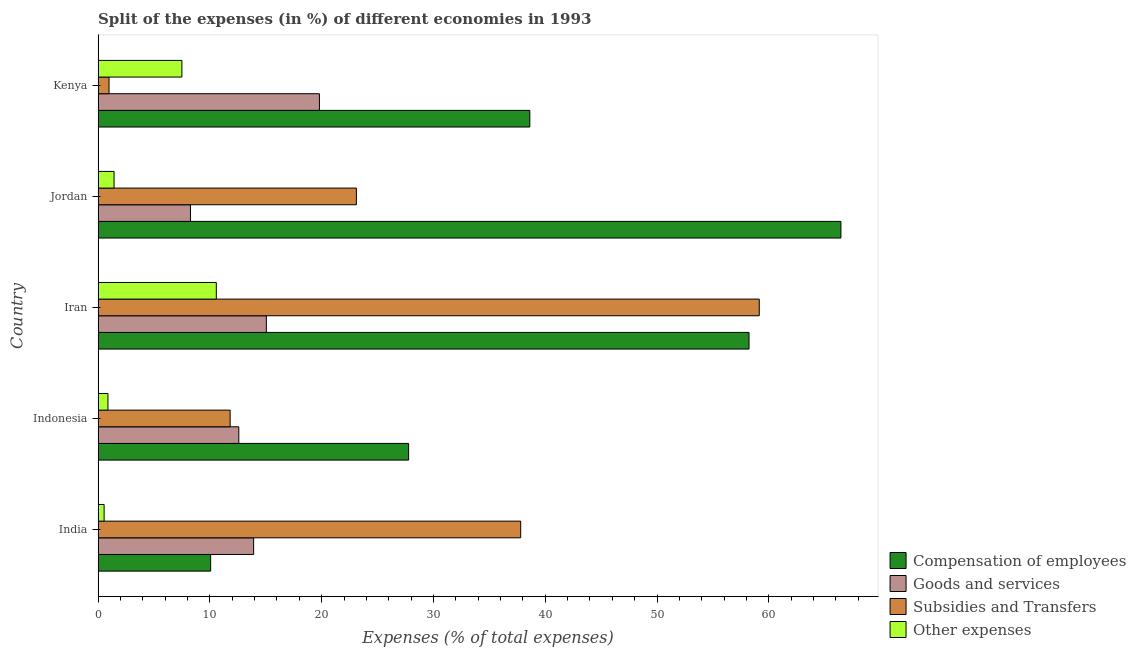How many different coloured bars are there?
Give a very brief answer. 4. How many groups of bars are there?
Provide a succinct answer. 5. How many bars are there on the 4th tick from the top?
Provide a short and direct response. 4. What is the label of the 1st group of bars from the top?
Make the answer very short. Kenya. In how many cases, is the number of bars for a given country not equal to the number of legend labels?
Your answer should be compact. 0. What is the percentage of amount spent on compensation of employees in Indonesia?
Offer a terse response. 27.78. Across all countries, what is the maximum percentage of amount spent on subsidies?
Your answer should be compact. 59.15. Across all countries, what is the minimum percentage of amount spent on other expenses?
Ensure brevity in your answer.  0.54. In which country was the percentage of amount spent on other expenses maximum?
Give a very brief answer. Iran. In which country was the percentage of amount spent on goods and services minimum?
Keep it short and to the point. Jordan. What is the total percentage of amount spent on goods and services in the graph?
Provide a short and direct response. 69.61. What is the difference between the percentage of amount spent on other expenses in Iran and that in Kenya?
Provide a short and direct response. 3.08. What is the difference between the percentage of amount spent on compensation of employees in Kenya and the percentage of amount spent on other expenses in Jordan?
Your answer should be very brief. 37.19. What is the average percentage of amount spent on other expenses per country?
Provide a succinct answer. 4.18. What is the difference between the percentage of amount spent on goods and services and percentage of amount spent on other expenses in Indonesia?
Provide a short and direct response. 11.71. What is the ratio of the percentage of amount spent on other expenses in India to that in Indonesia?
Your answer should be compact. 0.61. Is the percentage of amount spent on goods and services in India less than that in Iran?
Your answer should be very brief. Yes. What is the difference between the highest and the second highest percentage of amount spent on subsidies?
Keep it short and to the point. 21.34. What is the difference between the highest and the lowest percentage of amount spent on goods and services?
Provide a short and direct response. 11.53. What does the 1st bar from the top in India represents?
Keep it short and to the point. Other expenses. What does the 2nd bar from the bottom in Jordan represents?
Provide a short and direct response. Goods and services. How many bars are there?
Give a very brief answer. 20. Are all the bars in the graph horizontal?
Provide a succinct answer. Yes. How many countries are there in the graph?
Give a very brief answer. 5. Does the graph contain grids?
Your answer should be very brief. No. Where does the legend appear in the graph?
Keep it short and to the point. Bottom right. What is the title of the graph?
Your response must be concise. Split of the expenses (in %) of different economies in 1993. Does "Corruption" appear as one of the legend labels in the graph?
Offer a very short reply. No. What is the label or title of the X-axis?
Your response must be concise. Expenses (% of total expenses). What is the Expenses (% of total expenses) of Compensation of employees in India?
Give a very brief answer. 10.07. What is the Expenses (% of total expenses) of Goods and services in India?
Your response must be concise. 13.91. What is the Expenses (% of total expenses) in Subsidies and Transfers in India?
Your response must be concise. 37.8. What is the Expenses (% of total expenses) of Other expenses in India?
Provide a succinct answer. 0.54. What is the Expenses (% of total expenses) of Compensation of employees in Indonesia?
Your response must be concise. 27.78. What is the Expenses (% of total expenses) in Goods and services in Indonesia?
Your answer should be compact. 12.59. What is the Expenses (% of total expenses) of Subsidies and Transfers in Indonesia?
Ensure brevity in your answer.  11.81. What is the Expenses (% of total expenses) in Other expenses in Indonesia?
Your response must be concise. 0.88. What is the Expenses (% of total expenses) of Compensation of employees in Iran?
Provide a succinct answer. 58.23. What is the Expenses (% of total expenses) of Goods and services in Iran?
Give a very brief answer. 15.05. What is the Expenses (% of total expenses) of Subsidies and Transfers in Iran?
Offer a terse response. 59.15. What is the Expenses (% of total expenses) of Other expenses in Iran?
Offer a terse response. 10.57. What is the Expenses (% of total expenses) in Compensation of employees in Jordan?
Offer a terse response. 66.45. What is the Expenses (% of total expenses) in Goods and services in Jordan?
Give a very brief answer. 8.26. What is the Expenses (% of total expenses) in Subsidies and Transfers in Jordan?
Offer a terse response. 23.1. What is the Expenses (% of total expenses) of Other expenses in Jordan?
Offer a terse response. 1.43. What is the Expenses (% of total expenses) of Compensation of employees in Kenya?
Provide a succinct answer. 38.62. What is the Expenses (% of total expenses) of Goods and services in Kenya?
Provide a succinct answer. 19.8. What is the Expenses (% of total expenses) of Subsidies and Transfers in Kenya?
Your answer should be compact. 0.98. What is the Expenses (% of total expenses) in Other expenses in Kenya?
Your answer should be compact. 7.49. Across all countries, what is the maximum Expenses (% of total expenses) in Compensation of employees?
Offer a very short reply. 66.45. Across all countries, what is the maximum Expenses (% of total expenses) of Goods and services?
Offer a terse response. 19.8. Across all countries, what is the maximum Expenses (% of total expenses) in Subsidies and Transfers?
Your answer should be compact. 59.15. Across all countries, what is the maximum Expenses (% of total expenses) of Other expenses?
Your response must be concise. 10.57. Across all countries, what is the minimum Expenses (% of total expenses) in Compensation of employees?
Provide a short and direct response. 10.07. Across all countries, what is the minimum Expenses (% of total expenses) in Goods and services?
Make the answer very short. 8.26. Across all countries, what is the minimum Expenses (% of total expenses) in Subsidies and Transfers?
Your response must be concise. 0.98. Across all countries, what is the minimum Expenses (% of total expenses) in Other expenses?
Make the answer very short. 0.54. What is the total Expenses (% of total expenses) of Compensation of employees in the graph?
Offer a terse response. 201.15. What is the total Expenses (% of total expenses) in Goods and services in the graph?
Your answer should be very brief. 69.61. What is the total Expenses (% of total expenses) in Subsidies and Transfers in the graph?
Your answer should be very brief. 132.84. What is the total Expenses (% of total expenses) of Other expenses in the graph?
Provide a succinct answer. 20.91. What is the difference between the Expenses (% of total expenses) of Compensation of employees in India and that in Indonesia?
Ensure brevity in your answer.  -17.71. What is the difference between the Expenses (% of total expenses) of Goods and services in India and that in Indonesia?
Offer a very short reply. 1.33. What is the difference between the Expenses (% of total expenses) of Subsidies and Transfers in India and that in Indonesia?
Provide a short and direct response. 25.99. What is the difference between the Expenses (% of total expenses) in Other expenses in India and that in Indonesia?
Offer a terse response. -0.34. What is the difference between the Expenses (% of total expenses) in Compensation of employees in India and that in Iran?
Give a very brief answer. -48.16. What is the difference between the Expenses (% of total expenses) in Goods and services in India and that in Iran?
Offer a terse response. -1.14. What is the difference between the Expenses (% of total expenses) of Subsidies and Transfers in India and that in Iran?
Your response must be concise. -21.34. What is the difference between the Expenses (% of total expenses) in Other expenses in India and that in Iran?
Your response must be concise. -10.04. What is the difference between the Expenses (% of total expenses) of Compensation of employees in India and that in Jordan?
Your response must be concise. -56.38. What is the difference between the Expenses (% of total expenses) in Goods and services in India and that in Jordan?
Provide a short and direct response. 5.65. What is the difference between the Expenses (% of total expenses) in Subsidies and Transfers in India and that in Jordan?
Offer a terse response. 14.7. What is the difference between the Expenses (% of total expenses) of Other expenses in India and that in Jordan?
Provide a succinct answer. -0.89. What is the difference between the Expenses (% of total expenses) in Compensation of employees in India and that in Kenya?
Provide a short and direct response. -28.55. What is the difference between the Expenses (% of total expenses) of Goods and services in India and that in Kenya?
Offer a terse response. -5.89. What is the difference between the Expenses (% of total expenses) of Subsidies and Transfers in India and that in Kenya?
Provide a succinct answer. 36.83. What is the difference between the Expenses (% of total expenses) of Other expenses in India and that in Kenya?
Keep it short and to the point. -6.96. What is the difference between the Expenses (% of total expenses) of Compensation of employees in Indonesia and that in Iran?
Offer a very short reply. -30.45. What is the difference between the Expenses (% of total expenses) of Goods and services in Indonesia and that in Iran?
Ensure brevity in your answer.  -2.46. What is the difference between the Expenses (% of total expenses) in Subsidies and Transfers in Indonesia and that in Iran?
Your answer should be very brief. -47.34. What is the difference between the Expenses (% of total expenses) in Other expenses in Indonesia and that in Iran?
Ensure brevity in your answer.  -9.69. What is the difference between the Expenses (% of total expenses) of Compensation of employees in Indonesia and that in Jordan?
Your answer should be compact. -38.67. What is the difference between the Expenses (% of total expenses) in Goods and services in Indonesia and that in Jordan?
Your response must be concise. 4.32. What is the difference between the Expenses (% of total expenses) in Subsidies and Transfers in Indonesia and that in Jordan?
Provide a succinct answer. -11.29. What is the difference between the Expenses (% of total expenses) of Other expenses in Indonesia and that in Jordan?
Your response must be concise. -0.55. What is the difference between the Expenses (% of total expenses) in Compensation of employees in Indonesia and that in Kenya?
Your response must be concise. -10.84. What is the difference between the Expenses (% of total expenses) of Goods and services in Indonesia and that in Kenya?
Provide a succinct answer. -7.21. What is the difference between the Expenses (% of total expenses) of Subsidies and Transfers in Indonesia and that in Kenya?
Provide a succinct answer. 10.83. What is the difference between the Expenses (% of total expenses) of Other expenses in Indonesia and that in Kenya?
Provide a succinct answer. -6.62. What is the difference between the Expenses (% of total expenses) of Compensation of employees in Iran and that in Jordan?
Provide a short and direct response. -8.22. What is the difference between the Expenses (% of total expenses) in Goods and services in Iran and that in Jordan?
Offer a terse response. 6.79. What is the difference between the Expenses (% of total expenses) of Subsidies and Transfers in Iran and that in Jordan?
Make the answer very short. 36.04. What is the difference between the Expenses (% of total expenses) in Other expenses in Iran and that in Jordan?
Offer a very short reply. 9.15. What is the difference between the Expenses (% of total expenses) of Compensation of employees in Iran and that in Kenya?
Give a very brief answer. 19.61. What is the difference between the Expenses (% of total expenses) in Goods and services in Iran and that in Kenya?
Provide a succinct answer. -4.75. What is the difference between the Expenses (% of total expenses) in Subsidies and Transfers in Iran and that in Kenya?
Your response must be concise. 58.17. What is the difference between the Expenses (% of total expenses) in Other expenses in Iran and that in Kenya?
Keep it short and to the point. 3.08. What is the difference between the Expenses (% of total expenses) of Compensation of employees in Jordan and that in Kenya?
Make the answer very short. 27.83. What is the difference between the Expenses (% of total expenses) in Goods and services in Jordan and that in Kenya?
Offer a very short reply. -11.53. What is the difference between the Expenses (% of total expenses) in Subsidies and Transfers in Jordan and that in Kenya?
Make the answer very short. 22.13. What is the difference between the Expenses (% of total expenses) in Other expenses in Jordan and that in Kenya?
Keep it short and to the point. -6.07. What is the difference between the Expenses (% of total expenses) of Compensation of employees in India and the Expenses (% of total expenses) of Goods and services in Indonesia?
Keep it short and to the point. -2.52. What is the difference between the Expenses (% of total expenses) in Compensation of employees in India and the Expenses (% of total expenses) in Subsidies and Transfers in Indonesia?
Your answer should be very brief. -1.74. What is the difference between the Expenses (% of total expenses) of Compensation of employees in India and the Expenses (% of total expenses) of Other expenses in Indonesia?
Your response must be concise. 9.19. What is the difference between the Expenses (% of total expenses) in Goods and services in India and the Expenses (% of total expenses) in Subsidies and Transfers in Indonesia?
Ensure brevity in your answer.  2.1. What is the difference between the Expenses (% of total expenses) in Goods and services in India and the Expenses (% of total expenses) in Other expenses in Indonesia?
Offer a very short reply. 13.03. What is the difference between the Expenses (% of total expenses) of Subsidies and Transfers in India and the Expenses (% of total expenses) of Other expenses in Indonesia?
Ensure brevity in your answer.  36.93. What is the difference between the Expenses (% of total expenses) in Compensation of employees in India and the Expenses (% of total expenses) in Goods and services in Iran?
Your answer should be very brief. -4.98. What is the difference between the Expenses (% of total expenses) in Compensation of employees in India and the Expenses (% of total expenses) in Subsidies and Transfers in Iran?
Your response must be concise. -49.08. What is the difference between the Expenses (% of total expenses) of Compensation of employees in India and the Expenses (% of total expenses) of Other expenses in Iran?
Ensure brevity in your answer.  -0.51. What is the difference between the Expenses (% of total expenses) of Goods and services in India and the Expenses (% of total expenses) of Subsidies and Transfers in Iran?
Provide a short and direct response. -45.23. What is the difference between the Expenses (% of total expenses) of Goods and services in India and the Expenses (% of total expenses) of Other expenses in Iran?
Your answer should be compact. 3.34. What is the difference between the Expenses (% of total expenses) in Subsidies and Transfers in India and the Expenses (% of total expenses) in Other expenses in Iran?
Your answer should be very brief. 27.23. What is the difference between the Expenses (% of total expenses) in Compensation of employees in India and the Expenses (% of total expenses) in Goods and services in Jordan?
Provide a short and direct response. 1.8. What is the difference between the Expenses (% of total expenses) of Compensation of employees in India and the Expenses (% of total expenses) of Subsidies and Transfers in Jordan?
Your answer should be very brief. -13.04. What is the difference between the Expenses (% of total expenses) of Compensation of employees in India and the Expenses (% of total expenses) of Other expenses in Jordan?
Offer a very short reply. 8.64. What is the difference between the Expenses (% of total expenses) of Goods and services in India and the Expenses (% of total expenses) of Subsidies and Transfers in Jordan?
Give a very brief answer. -9.19. What is the difference between the Expenses (% of total expenses) of Goods and services in India and the Expenses (% of total expenses) of Other expenses in Jordan?
Offer a very short reply. 12.48. What is the difference between the Expenses (% of total expenses) in Subsidies and Transfers in India and the Expenses (% of total expenses) in Other expenses in Jordan?
Offer a terse response. 36.38. What is the difference between the Expenses (% of total expenses) of Compensation of employees in India and the Expenses (% of total expenses) of Goods and services in Kenya?
Your answer should be compact. -9.73. What is the difference between the Expenses (% of total expenses) of Compensation of employees in India and the Expenses (% of total expenses) of Subsidies and Transfers in Kenya?
Ensure brevity in your answer.  9.09. What is the difference between the Expenses (% of total expenses) in Compensation of employees in India and the Expenses (% of total expenses) in Other expenses in Kenya?
Make the answer very short. 2.57. What is the difference between the Expenses (% of total expenses) in Goods and services in India and the Expenses (% of total expenses) in Subsidies and Transfers in Kenya?
Provide a succinct answer. 12.94. What is the difference between the Expenses (% of total expenses) of Goods and services in India and the Expenses (% of total expenses) of Other expenses in Kenya?
Ensure brevity in your answer.  6.42. What is the difference between the Expenses (% of total expenses) in Subsidies and Transfers in India and the Expenses (% of total expenses) in Other expenses in Kenya?
Make the answer very short. 30.31. What is the difference between the Expenses (% of total expenses) in Compensation of employees in Indonesia and the Expenses (% of total expenses) in Goods and services in Iran?
Your answer should be compact. 12.73. What is the difference between the Expenses (% of total expenses) in Compensation of employees in Indonesia and the Expenses (% of total expenses) in Subsidies and Transfers in Iran?
Your answer should be very brief. -31.37. What is the difference between the Expenses (% of total expenses) of Compensation of employees in Indonesia and the Expenses (% of total expenses) of Other expenses in Iran?
Ensure brevity in your answer.  17.2. What is the difference between the Expenses (% of total expenses) in Goods and services in Indonesia and the Expenses (% of total expenses) in Subsidies and Transfers in Iran?
Your response must be concise. -46.56. What is the difference between the Expenses (% of total expenses) of Goods and services in Indonesia and the Expenses (% of total expenses) of Other expenses in Iran?
Your response must be concise. 2.01. What is the difference between the Expenses (% of total expenses) of Subsidies and Transfers in Indonesia and the Expenses (% of total expenses) of Other expenses in Iran?
Your answer should be very brief. 1.24. What is the difference between the Expenses (% of total expenses) in Compensation of employees in Indonesia and the Expenses (% of total expenses) in Goods and services in Jordan?
Provide a succinct answer. 19.52. What is the difference between the Expenses (% of total expenses) of Compensation of employees in Indonesia and the Expenses (% of total expenses) of Subsidies and Transfers in Jordan?
Provide a short and direct response. 4.67. What is the difference between the Expenses (% of total expenses) in Compensation of employees in Indonesia and the Expenses (% of total expenses) in Other expenses in Jordan?
Make the answer very short. 26.35. What is the difference between the Expenses (% of total expenses) of Goods and services in Indonesia and the Expenses (% of total expenses) of Subsidies and Transfers in Jordan?
Offer a very short reply. -10.52. What is the difference between the Expenses (% of total expenses) of Goods and services in Indonesia and the Expenses (% of total expenses) of Other expenses in Jordan?
Ensure brevity in your answer.  11.16. What is the difference between the Expenses (% of total expenses) of Subsidies and Transfers in Indonesia and the Expenses (% of total expenses) of Other expenses in Jordan?
Keep it short and to the point. 10.38. What is the difference between the Expenses (% of total expenses) in Compensation of employees in Indonesia and the Expenses (% of total expenses) in Goods and services in Kenya?
Keep it short and to the point. 7.98. What is the difference between the Expenses (% of total expenses) in Compensation of employees in Indonesia and the Expenses (% of total expenses) in Subsidies and Transfers in Kenya?
Your answer should be very brief. 26.8. What is the difference between the Expenses (% of total expenses) in Compensation of employees in Indonesia and the Expenses (% of total expenses) in Other expenses in Kenya?
Provide a succinct answer. 20.28. What is the difference between the Expenses (% of total expenses) in Goods and services in Indonesia and the Expenses (% of total expenses) in Subsidies and Transfers in Kenya?
Offer a terse response. 11.61. What is the difference between the Expenses (% of total expenses) in Goods and services in Indonesia and the Expenses (% of total expenses) in Other expenses in Kenya?
Keep it short and to the point. 5.09. What is the difference between the Expenses (% of total expenses) in Subsidies and Transfers in Indonesia and the Expenses (% of total expenses) in Other expenses in Kenya?
Provide a succinct answer. 4.32. What is the difference between the Expenses (% of total expenses) in Compensation of employees in Iran and the Expenses (% of total expenses) in Goods and services in Jordan?
Make the answer very short. 49.97. What is the difference between the Expenses (% of total expenses) in Compensation of employees in Iran and the Expenses (% of total expenses) in Subsidies and Transfers in Jordan?
Offer a terse response. 35.13. What is the difference between the Expenses (% of total expenses) in Compensation of employees in Iran and the Expenses (% of total expenses) in Other expenses in Jordan?
Make the answer very short. 56.8. What is the difference between the Expenses (% of total expenses) of Goods and services in Iran and the Expenses (% of total expenses) of Subsidies and Transfers in Jordan?
Your answer should be very brief. -8.05. What is the difference between the Expenses (% of total expenses) of Goods and services in Iran and the Expenses (% of total expenses) of Other expenses in Jordan?
Keep it short and to the point. 13.62. What is the difference between the Expenses (% of total expenses) of Subsidies and Transfers in Iran and the Expenses (% of total expenses) of Other expenses in Jordan?
Offer a terse response. 57.72. What is the difference between the Expenses (% of total expenses) of Compensation of employees in Iran and the Expenses (% of total expenses) of Goods and services in Kenya?
Keep it short and to the point. 38.43. What is the difference between the Expenses (% of total expenses) of Compensation of employees in Iran and the Expenses (% of total expenses) of Subsidies and Transfers in Kenya?
Your answer should be very brief. 57.25. What is the difference between the Expenses (% of total expenses) of Compensation of employees in Iran and the Expenses (% of total expenses) of Other expenses in Kenya?
Provide a succinct answer. 50.74. What is the difference between the Expenses (% of total expenses) of Goods and services in Iran and the Expenses (% of total expenses) of Subsidies and Transfers in Kenya?
Provide a succinct answer. 14.07. What is the difference between the Expenses (% of total expenses) in Goods and services in Iran and the Expenses (% of total expenses) in Other expenses in Kenya?
Provide a succinct answer. 7.56. What is the difference between the Expenses (% of total expenses) of Subsidies and Transfers in Iran and the Expenses (% of total expenses) of Other expenses in Kenya?
Make the answer very short. 51.65. What is the difference between the Expenses (% of total expenses) of Compensation of employees in Jordan and the Expenses (% of total expenses) of Goods and services in Kenya?
Keep it short and to the point. 46.65. What is the difference between the Expenses (% of total expenses) in Compensation of employees in Jordan and the Expenses (% of total expenses) in Subsidies and Transfers in Kenya?
Your answer should be compact. 65.47. What is the difference between the Expenses (% of total expenses) of Compensation of employees in Jordan and the Expenses (% of total expenses) of Other expenses in Kenya?
Provide a succinct answer. 58.96. What is the difference between the Expenses (% of total expenses) of Goods and services in Jordan and the Expenses (% of total expenses) of Subsidies and Transfers in Kenya?
Ensure brevity in your answer.  7.29. What is the difference between the Expenses (% of total expenses) of Goods and services in Jordan and the Expenses (% of total expenses) of Other expenses in Kenya?
Offer a very short reply. 0.77. What is the difference between the Expenses (% of total expenses) in Subsidies and Transfers in Jordan and the Expenses (% of total expenses) in Other expenses in Kenya?
Provide a succinct answer. 15.61. What is the average Expenses (% of total expenses) in Compensation of employees per country?
Offer a very short reply. 40.23. What is the average Expenses (% of total expenses) in Goods and services per country?
Your answer should be compact. 13.92. What is the average Expenses (% of total expenses) of Subsidies and Transfers per country?
Offer a very short reply. 26.57. What is the average Expenses (% of total expenses) in Other expenses per country?
Offer a terse response. 4.18. What is the difference between the Expenses (% of total expenses) in Compensation of employees and Expenses (% of total expenses) in Goods and services in India?
Your answer should be compact. -3.84. What is the difference between the Expenses (% of total expenses) in Compensation of employees and Expenses (% of total expenses) in Subsidies and Transfers in India?
Offer a terse response. -27.74. What is the difference between the Expenses (% of total expenses) in Compensation of employees and Expenses (% of total expenses) in Other expenses in India?
Provide a succinct answer. 9.53. What is the difference between the Expenses (% of total expenses) in Goods and services and Expenses (% of total expenses) in Subsidies and Transfers in India?
Give a very brief answer. -23.89. What is the difference between the Expenses (% of total expenses) in Goods and services and Expenses (% of total expenses) in Other expenses in India?
Offer a terse response. 13.37. What is the difference between the Expenses (% of total expenses) of Subsidies and Transfers and Expenses (% of total expenses) of Other expenses in India?
Provide a succinct answer. 37.27. What is the difference between the Expenses (% of total expenses) of Compensation of employees and Expenses (% of total expenses) of Goods and services in Indonesia?
Provide a short and direct response. 15.19. What is the difference between the Expenses (% of total expenses) of Compensation of employees and Expenses (% of total expenses) of Subsidies and Transfers in Indonesia?
Offer a terse response. 15.97. What is the difference between the Expenses (% of total expenses) of Compensation of employees and Expenses (% of total expenses) of Other expenses in Indonesia?
Your answer should be very brief. 26.9. What is the difference between the Expenses (% of total expenses) in Goods and services and Expenses (% of total expenses) in Subsidies and Transfers in Indonesia?
Offer a terse response. 0.78. What is the difference between the Expenses (% of total expenses) of Goods and services and Expenses (% of total expenses) of Other expenses in Indonesia?
Make the answer very short. 11.71. What is the difference between the Expenses (% of total expenses) of Subsidies and Transfers and Expenses (% of total expenses) of Other expenses in Indonesia?
Keep it short and to the point. 10.93. What is the difference between the Expenses (% of total expenses) of Compensation of employees and Expenses (% of total expenses) of Goods and services in Iran?
Provide a succinct answer. 43.18. What is the difference between the Expenses (% of total expenses) in Compensation of employees and Expenses (% of total expenses) in Subsidies and Transfers in Iran?
Provide a short and direct response. -0.92. What is the difference between the Expenses (% of total expenses) of Compensation of employees and Expenses (% of total expenses) of Other expenses in Iran?
Offer a very short reply. 47.66. What is the difference between the Expenses (% of total expenses) in Goods and services and Expenses (% of total expenses) in Subsidies and Transfers in Iran?
Your answer should be compact. -44.1. What is the difference between the Expenses (% of total expenses) in Goods and services and Expenses (% of total expenses) in Other expenses in Iran?
Give a very brief answer. 4.48. What is the difference between the Expenses (% of total expenses) in Subsidies and Transfers and Expenses (% of total expenses) in Other expenses in Iran?
Make the answer very short. 48.57. What is the difference between the Expenses (% of total expenses) of Compensation of employees and Expenses (% of total expenses) of Goods and services in Jordan?
Give a very brief answer. 58.19. What is the difference between the Expenses (% of total expenses) of Compensation of employees and Expenses (% of total expenses) of Subsidies and Transfers in Jordan?
Your answer should be very brief. 43.35. What is the difference between the Expenses (% of total expenses) of Compensation of employees and Expenses (% of total expenses) of Other expenses in Jordan?
Keep it short and to the point. 65.02. What is the difference between the Expenses (% of total expenses) in Goods and services and Expenses (% of total expenses) in Subsidies and Transfers in Jordan?
Give a very brief answer. -14.84. What is the difference between the Expenses (% of total expenses) in Goods and services and Expenses (% of total expenses) in Other expenses in Jordan?
Offer a terse response. 6.84. What is the difference between the Expenses (% of total expenses) in Subsidies and Transfers and Expenses (% of total expenses) in Other expenses in Jordan?
Give a very brief answer. 21.68. What is the difference between the Expenses (% of total expenses) of Compensation of employees and Expenses (% of total expenses) of Goods and services in Kenya?
Offer a terse response. 18.82. What is the difference between the Expenses (% of total expenses) of Compensation of employees and Expenses (% of total expenses) of Subsidies and Transfers in Kenya?
Offer a very short reply. 37.64. What is the difference between the Expenses (% of total expenses) of Compensation of employees and Expenses (% of total expenses) of Other expenses in Kenya?
Keep it short and to the point. 31.13. What is the difference between the Expenses (% of total expenses) in Goods and services and Expenses (% of total expenses) in Subsidies and Transfers in Kenya?
Ensure brevity in your answer.  18.82. What is the difference between the Expenses (% of total expenses) of Goods and services and Expenses (% of total expenses) of Other expenses in Kenya?
Your response must be concise. 12.3. What is the difference between the Expenses (% of total expenses) of Subsidies and Transfers and Expenses (% of total expenses) of Other expenses in Kenya?
Offer a very short reply. -6.52. What is the ratio of the Expenses (% of total expenses) of Compensation of employees in India to that in Indonesia?
Your answer should be very brief. 0.36. What is the ratio of the Expenses (% of total expenses) of Goods and services in India to that in Indonesia?
Ensure brevity in your answer.  1.11. What is the ratio of the Expenses (% of total expenses) of Subsidies and Transfers in India to that in Indonesia?
Make the answer very short. 3.2. What is the ratio of the Expenses (% of total expenses) in Other expenses in India to that in Indonesia?
Make the answer very short. 0.61. What is the ratio of the Expenses (% of total expenses) of Compensation of employees in India to that in Iran?
Give a very brief answer. 0.17. What is the ratio of the Expenses (% of total expenses) in Goods and services in India to that in Iran?
Ensure brevity in your answer.  0.92. What is the ratio of the Expenses (% of total expenses) in Subsidies and Transfers in India to that in Iran?
Provide a succinct answer. 0.64. What is the ratio of the Expenses (% of total expenses) of Other expenses in India to that in Iran?
Make the answer very short. 0.05. What is the ratio of the Expenses (% of total expenses) in Compensation of employees in India to that in Jordan?
Your answer should be compact. 0.15. What is the ratio of the Expenses (% of total expenses) of Goods and services in India to that in Jordan?
Your answer should be very brief. 1.68. What is the ratio of the Expenses (% of total expenses) in Subsidies and Transfers in India to that in Jordan?
Keep it short and to the point. 1.64. What is the ratio of the Expenses (% of total expenses) in Other expenses in India to that in Jordan?
Your answer should be compact. 0.38. What is the ratio of the Expenses (% of total expenses) in Compensation of employees in India to that in Kenya?
Make the answer very short. 0.26. What is the ratio of the Expenses (% of total expenses) of Goods and services in India to that in Kenya?
Your answer should be compact. 0.7. What is the ratio of the Expenses (% of total expenses) in Subsidies and Transfers in India to that in Kenya?
Offer a very short reply. 38.7. What is the ratio of the Expenses (% of total expenses) of Other expenses in India to that in Kenya?
Offer a very short reply. 0.07. What is the ratio of the Expenses (% of total expenses) in Compensation of employees in Indonesia to that in Iran?
Your answer should be compact. 0.48. What is the ratio of the Expenses (% of total expenses) in Goods and services in Indonesia to that in Iran?
Provide a short and direct response. 0.84. What is the ratio of the Expenses (% of total expenses) of Subsidies and Transfers in Indonesia to that in Iran?
Provide a succinct answer. 0.2. What is the ratio of the Expenses (% of total expenses) in Other expenses in Indonesia to that in Iran?
Your answer should be compact. 0.08. What is the ratio of the Expenses (% of total expenses) in Compensation of employees in Indonesia to that in Jordan?
Give a very brief answer. 0.42. What is the ratio of the Expenses (% of total expenses) in Goods and services in Indonesia to that in Jordan?
Give a very brief answer. 1.52. What is the ratio of the Expenses (% of total expenses) of Subsidies and Transfers in Indonesia to that in Jordan?
Your response must be concise. 0.51. What is the ratio of the Expenses (% of total expenses) of Other expenses in Indonesia to that in Jordan?
Offer a very short reply. 0.62. What is the ratio of the Expenses (% of total expenses) in Compensation of employees in Indonesia to that in Kenya?
Give a very brief answer. 0.72. What is the ratio of the Expenses (% of total expenses) of Goods and services in Indonesia to that in Kenya?
Provide a succinct answer. 0.64. What is the ratio of the Expenses (% of total expenses) in Subsidies and Transfers in Indonesia to that in Kenya?
Give a very brief answer. 12.09. What is the ratio of the Expenses (% of total expenses) in Other expenses in Indonesia to that in Kenya?
Your answer should be compact. 0.12. What is the ratio of the Expenses (% of total expenses) of Compensation of employees in Iran to that in Jordan?
Give a very brief answer. 0.88. What is the ratio of the Expenses (% of total expenses) of Goods and services in Iran to that in Jordan?
Offer a terse response. 1.82. What is the ratio of the Expenses (% of total expenses) of Subsidies and Transfers in Iran to that in Jordan?
Ensure brevity in your answer.  2.56. What is the ratio of the Expenses (% of total expenses) of Other expenses in Iran to that in Jordan?
Give a very brief answer. 7.41. What is the ratio of the Expenses (% of total expenses) in Compensation of employees in Iran to that in Kenya?
Make the answer very short. 1.51. What is the ratio of the Expenses (% of total expenses) of Goods and services in Iran to that in Kenya?
Offer a terse response. 0.76. What is the ratio of the Expenses (% of total expenses) in Subsidies and Transfers in Iran to that in Kenya?
Your answer should be compact. 60.55. What is the ratio of the Expenses (% of total expenses) in Other expenses in Iran to that in Kenya?
Make the answer very short. 1.41. What is the ratio of the Expenses (% of total expenses) of Compensation of employees in Jordan to that in Kenya?
Provide a succinct answer. 1.72. What is the ratio of the Expenses (% of total expenses) of Goods and services in Jordan to that in Kenya?
Ensure brevity in your answer.  0.42. What is the ratio of the Expenses (% of total expenses) of Subsidies and Transfers in Jordan to that in Kenya?
Make the answer very short. 23.65. What is the ratio of the Expenses (% of total expenses) of Other expenses in Jordan to that in Kenya?
Give a very brief answer. 0.19. What is the difference between the highest and the second highest Expenses (% of total expenses) in Compensation of employees?
Your response must be concise. 8.22. What is the difference between the highest and the second highest Expenses (% of total expenses) of Goods and services?
Ensure brevity in your answer.  4.75. What is the difference between the highest and the second highest Expenses (% of total expenses) of Subsidies and Transfers?
Offer a very short reply. 21.34. What is the difference between the highest and the second highest Expenses (% of total expenses) in Other expenses?
Offer a very short reply. 3.08. What is the difference between the highest and the lowest Expenses (% of total expenses) in Compensation of employees?
Offer a very short reply. 56.38. What is the difference between the highest and the lowest Expenses (% of total expenses) of Goods and services?
Your response must be concise. 11.53. What is the difference between the highest and the lowest Expenses (% of total expenses) of Subsidies and Transfers?
Ensure brevity in your answer.  58.17. What is the difference between the highest and the lowest Expenses (% of total expenses) in Other expenses?
Provide a succinct answer. 10.04. 